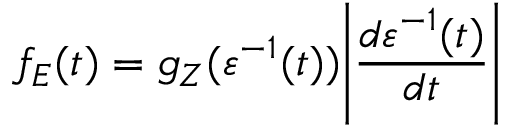<formula> <loc_0><loc_0><loc_500><loc_500>f _ { E } ( t ) = g _ { Z } ( \varepsilon ^ { - 1 } ( t ) ) \left | \frac { d \varepsilon ^ { - 1 } ( t ) } { d t } \right |</formula> 